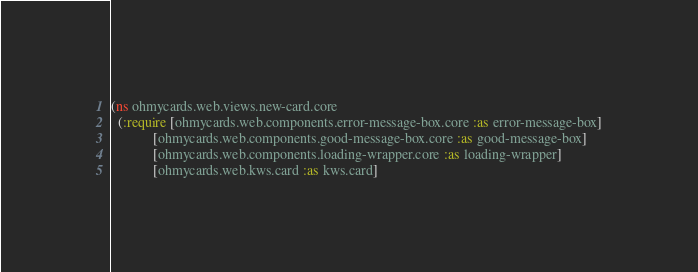<code> <loc_0><loc_0><loc_500><loc_500><_Clojure_>(ns ohmycards.web.views.new-card.core
  (:require [ohmycards.web.components.error-message-box.core :as error-message-box]
            [ohmycards.web.components.good-message-box.core :as good-message-box]
            [ohmycards.web.components.loading-wrapper.core :as loading-wrapper]
            [ohmycards.web.kws.card :as kws.card]</code> 